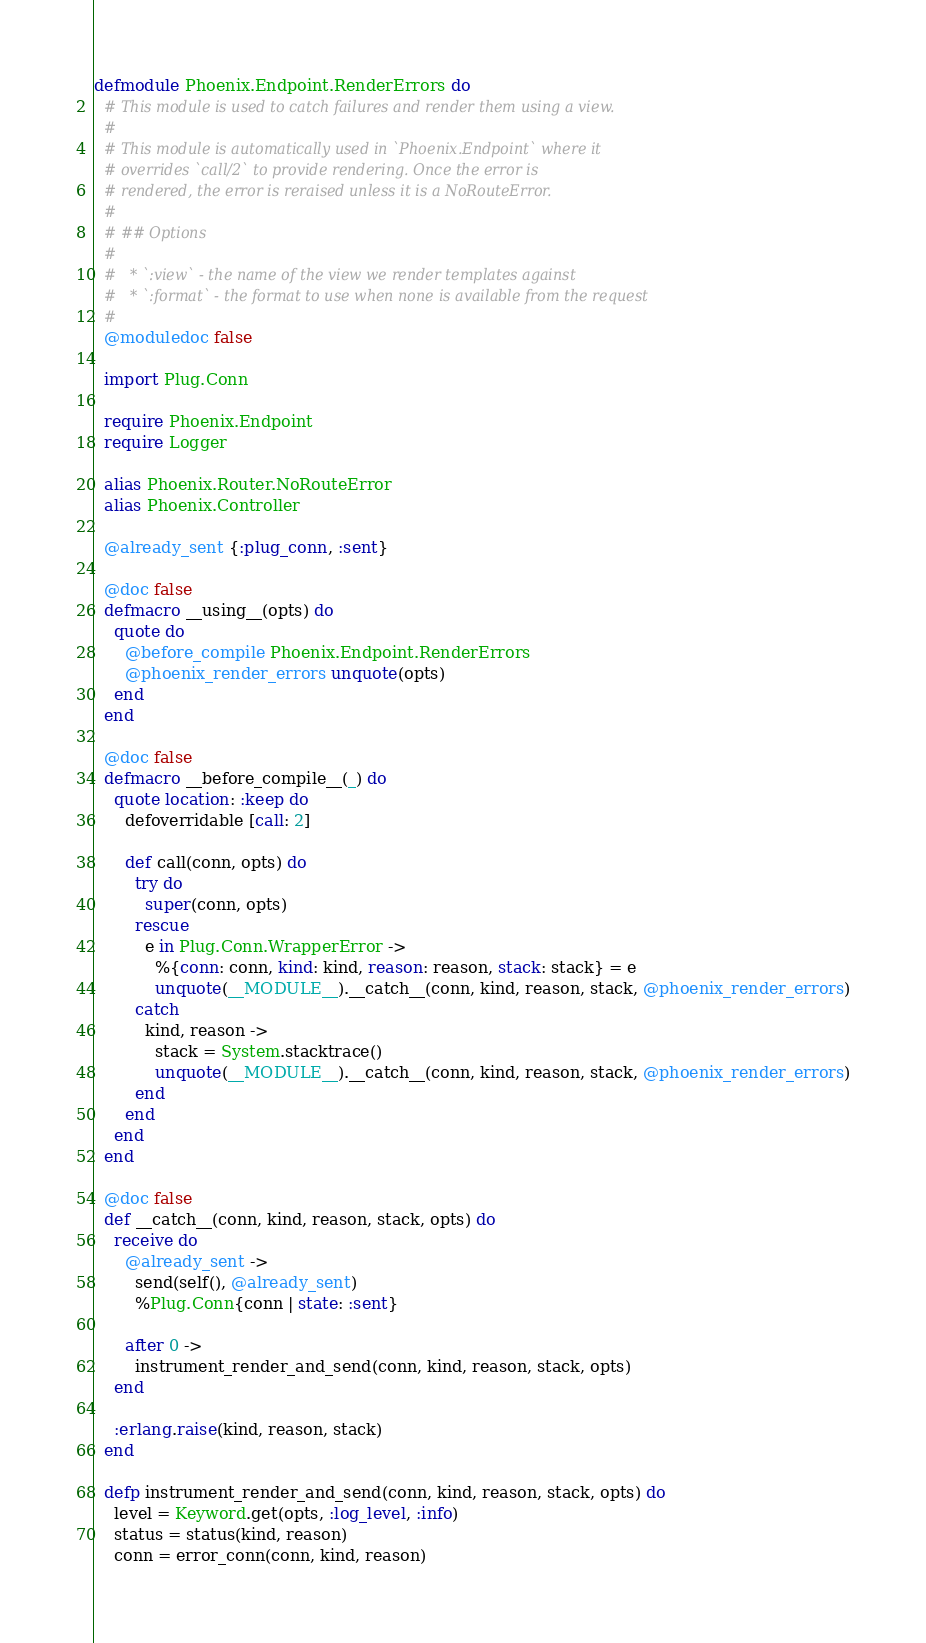Convert code to text. <code><loc_0><loc_0><loc_500><loc_500><_Elixir_>defmodule Phoenix.Endpoint.RenderErrors do
  # This module is used to catch failures and render them using a view.
  #
  # This module is automatically used in `Phoenix.Endpoint` where it
  # overrides `call/2` to provide rendering. Once the error is
  # rendered, the error is reraised unless it is a NoRouteError.
  #
  # ## Options
  #
  #   * `:view` - the name of the view we render templates against
  #   * `:format` - the format to use when none is available from the request
  #
  @moduledoc false

  import Plug.Conn

  require Phoenix.Endpoint
  require Logger

  alias Phoenix.Router.NoRouteError
  alias Phoenix.Controller

  @already_sent {:plug_conn, :sent}

  @doc false
  defmacro __using__(opts) do
    quote do
      @before_compile Phoenix.Endpoint.RenderErrors
      @phoenix_render_errors unquote(opts)
    end
  end

  @doc false
  defmacro __before_compile__(_) do
    quote location: :keep do
      defoverridable [call: 2]

      def call(conn, opts) do
        try do
          super(conn, opts)
        rescue
          e in Plug.Conn.WrapperError ->
            %{conn: conn, kind: kind, reason: reason, stack: stack} = e
            unquote(__MODULE__).__catch__(conn, kind, reason, stack, @phoenix_render_errors)
        catch
          kind, reason ->
            stack = System.stacktrace()
            unquote(__MODULE__).__catch__(conn, kind, reason, stack, @phoenix_render_errors)
        end
      end
    end
  end

  @doc false
  def __catch__(conn, kind, reason, stack, opts) do
    receive do
      @already_sent ->
        send(self(), @already_sent)
        %Plug.Conn{conn | state: :sent}

      after 0 ->
        instrument_render_and_send(conn, kind, reason, stack, opts)
    end

    :erlang.raise(kind, reason, stack)
  end

  defp instrument_render_and_send(conn, kind, reason, stack, opts) do
    level = Keyword.get(opts, :log_level, :info)
    status = status(kind, reason)
    conn = error_conn(conn, kind, reason)</code> 